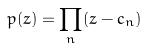<formula> <loc_0><loc_0><loc_500><loc_500>p ( z ) = \prod _ { n } ( z - c _ { n } )</formula> 